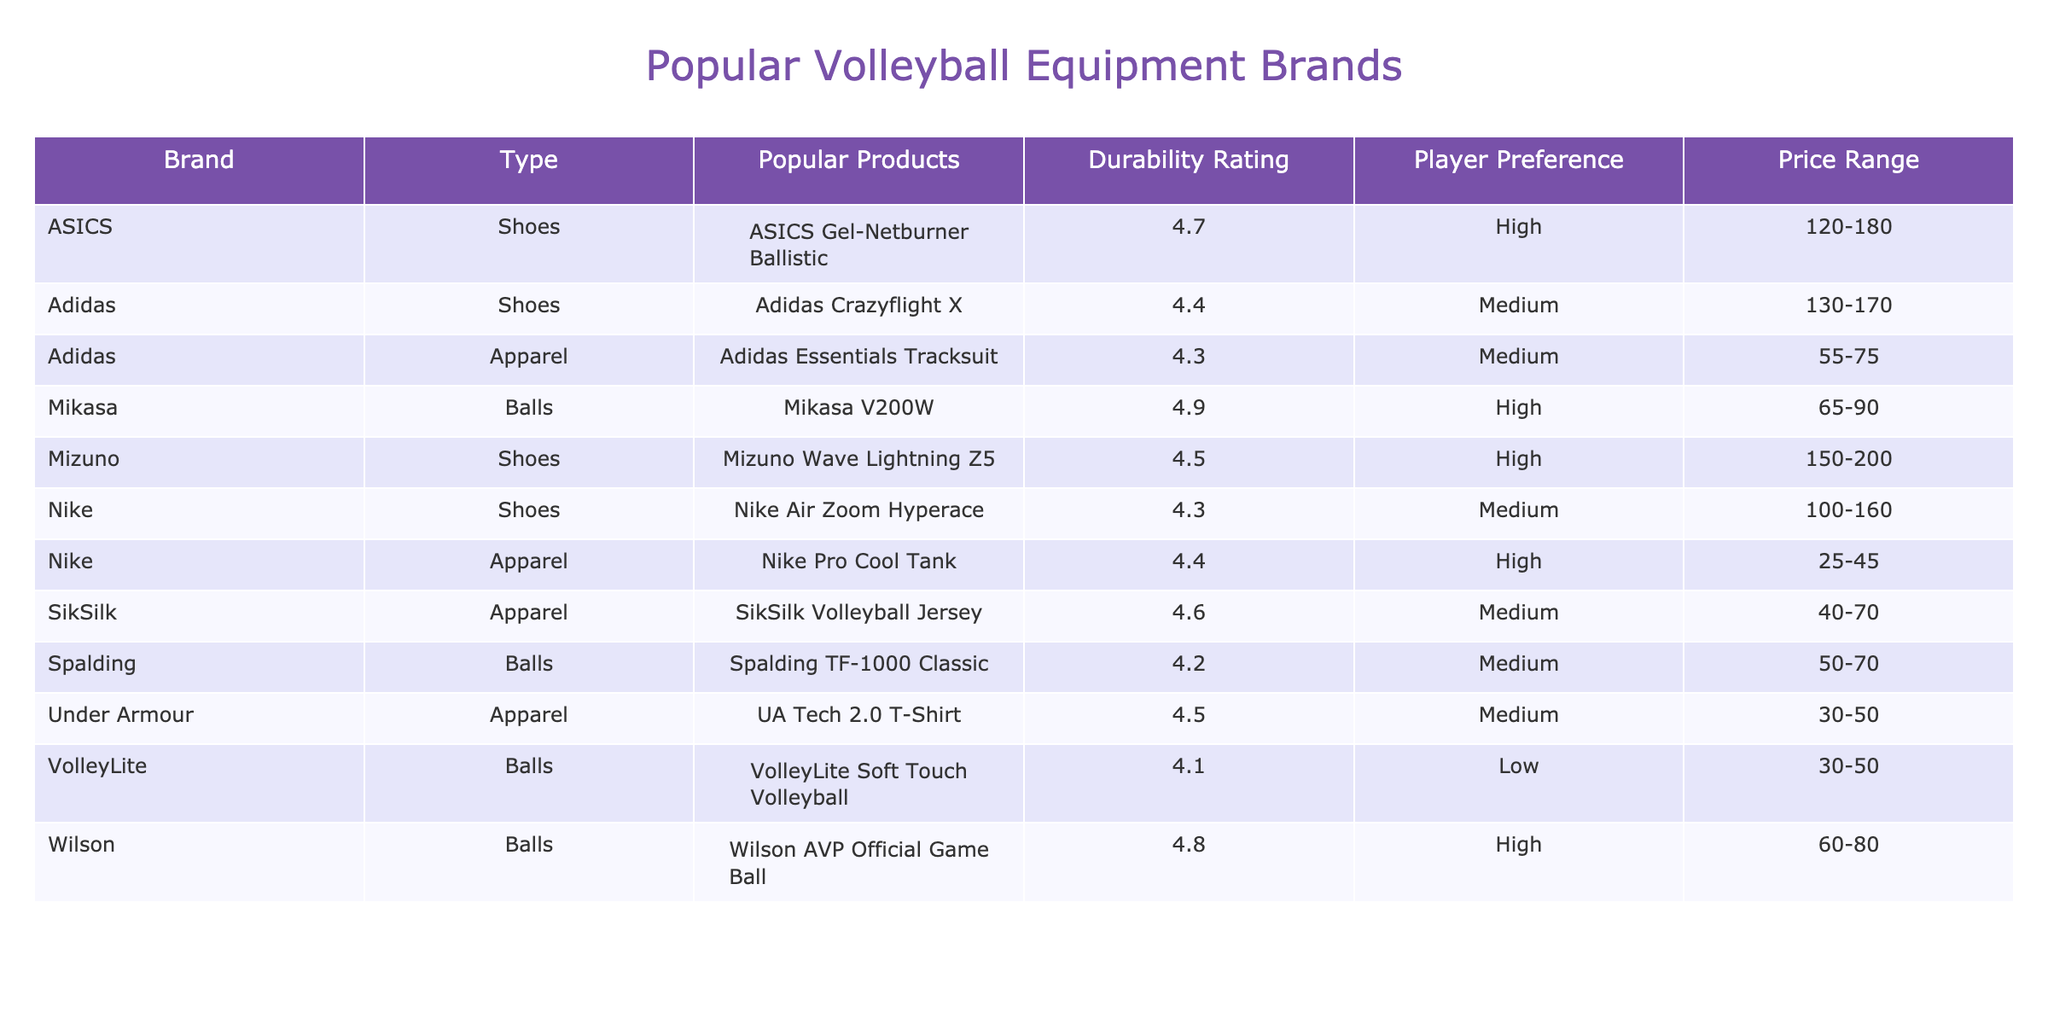What brand has the highest durability rating for shoes? In the table, the durability ratings for shoes are as follows: Mizuno Wave Lightning Z5 has a rating of 4.5, ASICS Gel-Netburner Ballistic has a rating of 4.7, Nike Air Zoom Hyperace has a rating of 4.3, and Adidas Crazyflight X has a rating of 4.4. The highest rating among these is ASICS Gel-Netburner Ballistic with a rating of 4.7
Answer: ASICS Which volleyball has the lowest player preference? The player preferences listed for each volleyball are: Wilson AVP Official Game Ball (High), Mikasa V200W (High), Spalding TF-1000 Classic (Medium), and VolleyLite Soft Touch Volleyball (Low). Since VolleyLite has the lowest preference categorized as Low, it answers the question
Answer: VolleyLite Soft Touch Volleyball Is the Nike Air Zoom Hyperace a low or high durability shoe? The Nike Air Zoom Hyperace has a durability rating of 4.3, which categorizes it under Medium durability according to the table. Therefore, it is not classified as low or high. The specifications clearly mention 'Medium'
Answer: Medium What is the average price range of the volleyballs listed? The price ranges for the volleyballs are: Wilson AVP Official Game Ball (60-80), Mikasa V200W (65-90), Spalding TF-1000 Classic (50-70), and VolleyLite Soft Touch Volleyball (30-50). We first average the lower and upper bounds of these ranges: (60+65+50+30)/4 = 51.25 for the lower bound and (80+90+70+50)/4 = 72.5 for the upper bound. Thus, the average price range for the volleyballs is 51.25-72.5
Answer: 51.25-72.5 Which brand has a higher durability rating, Nike or Adidas shoes? The durability ratings for Nike Air Zoom Hyperace and Adidas Crazyflight X are 4.3 and 4.4, respectively. By comparing these two values, Adidas Crazyflight X has a higher durability rating than Nike
Answer: Adidas 